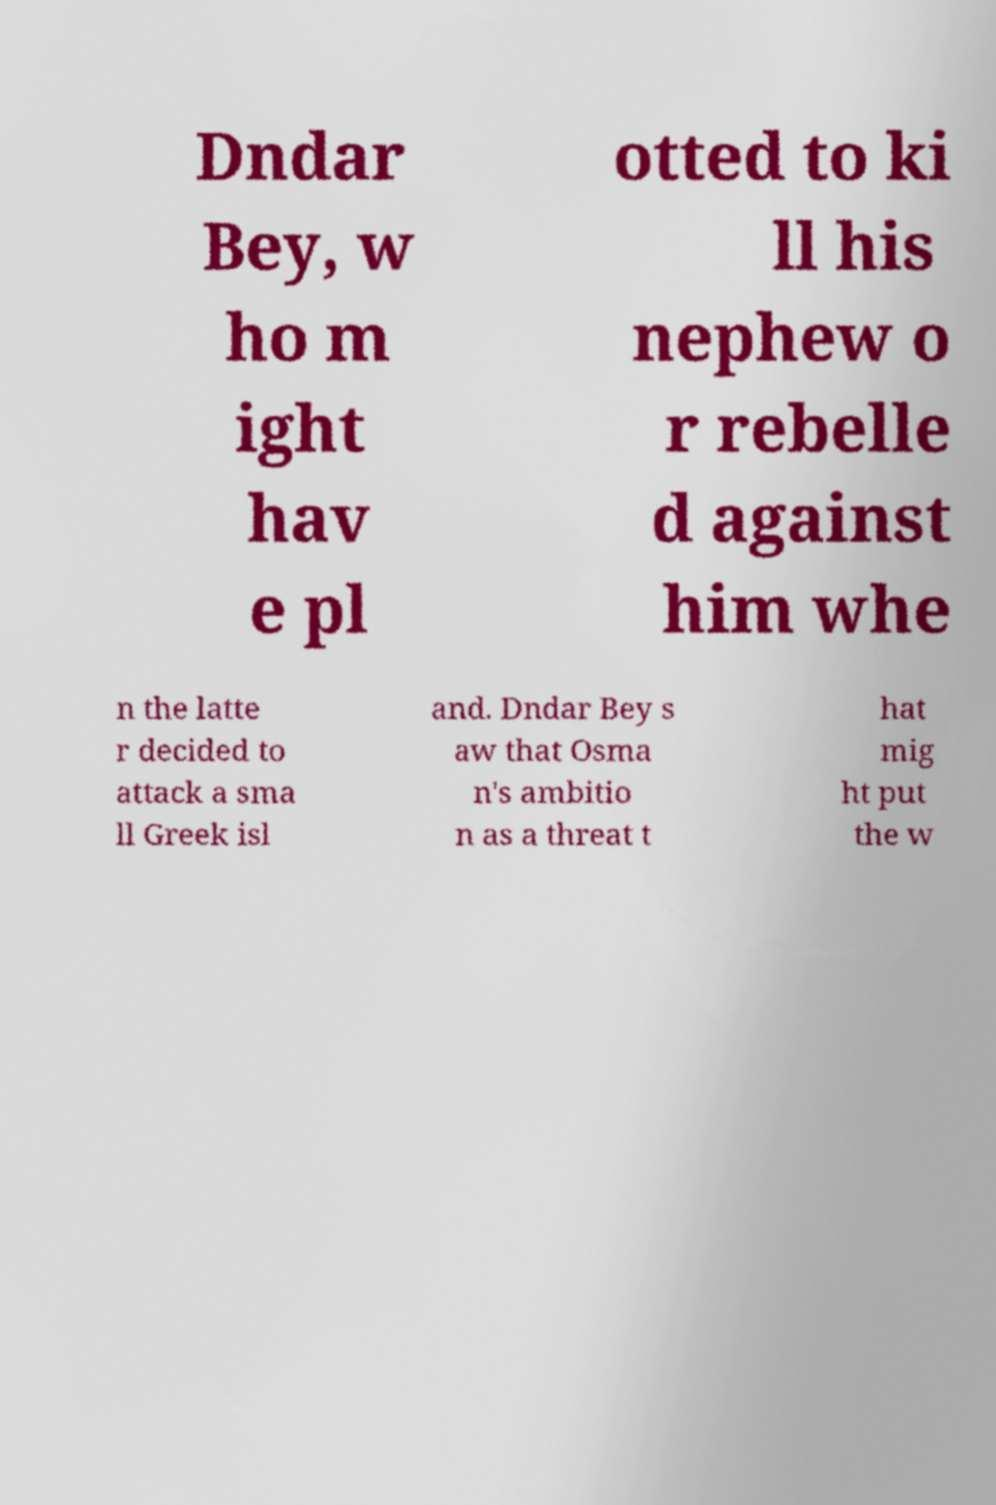There's text embedded in this image that I need extracted. Can you transcribe it verbatim? Dndar Bey, w ho m ight hav e pl otted to ki ll his nephew o r rebelle d against him whe n the latte r decided to attack a sma ll Greek isl and. Dndar Bey s aw that Osma n's ambitio n as a threat t hat mig ht put the w 